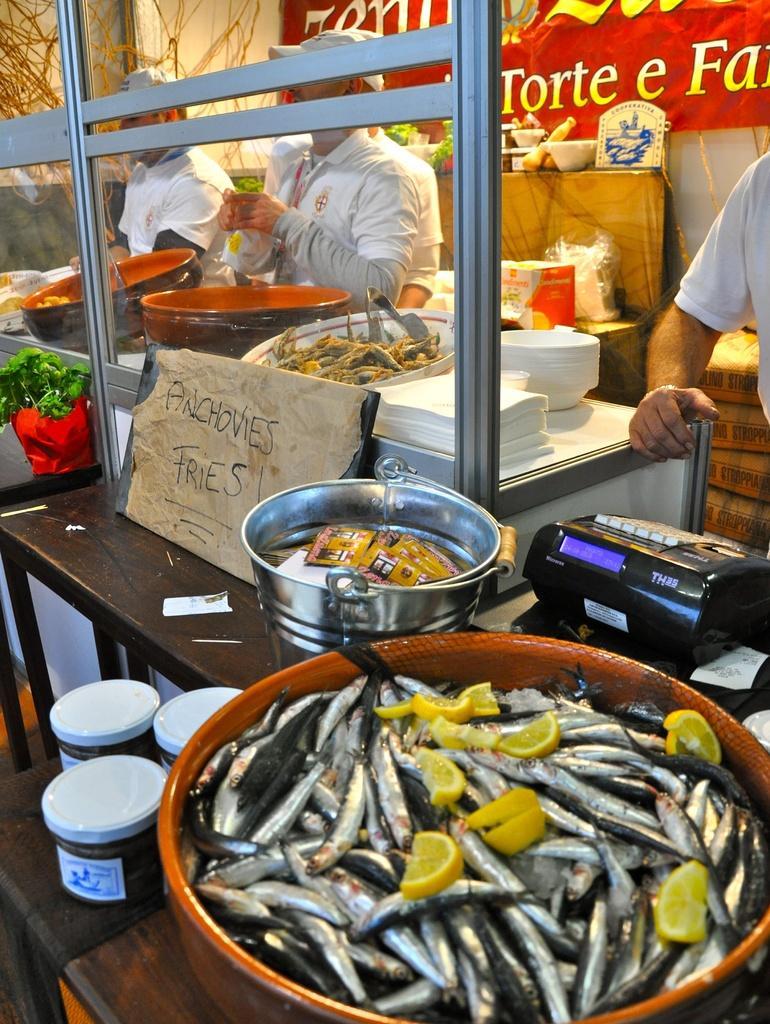Could you give a brief overview of what you see in this image? In this picture we can see lemon pieces and fish in the bowl, beside the bowl we can find few bottles, bucket, machine and other things on the countertop, in the background we can see few people, plates, bowls and a hoarding. 